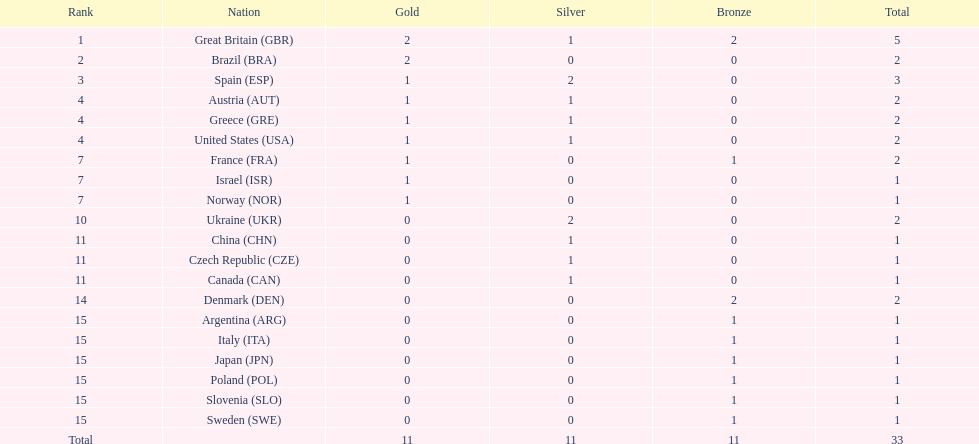How many silver medals has ukraine secured? 2. 